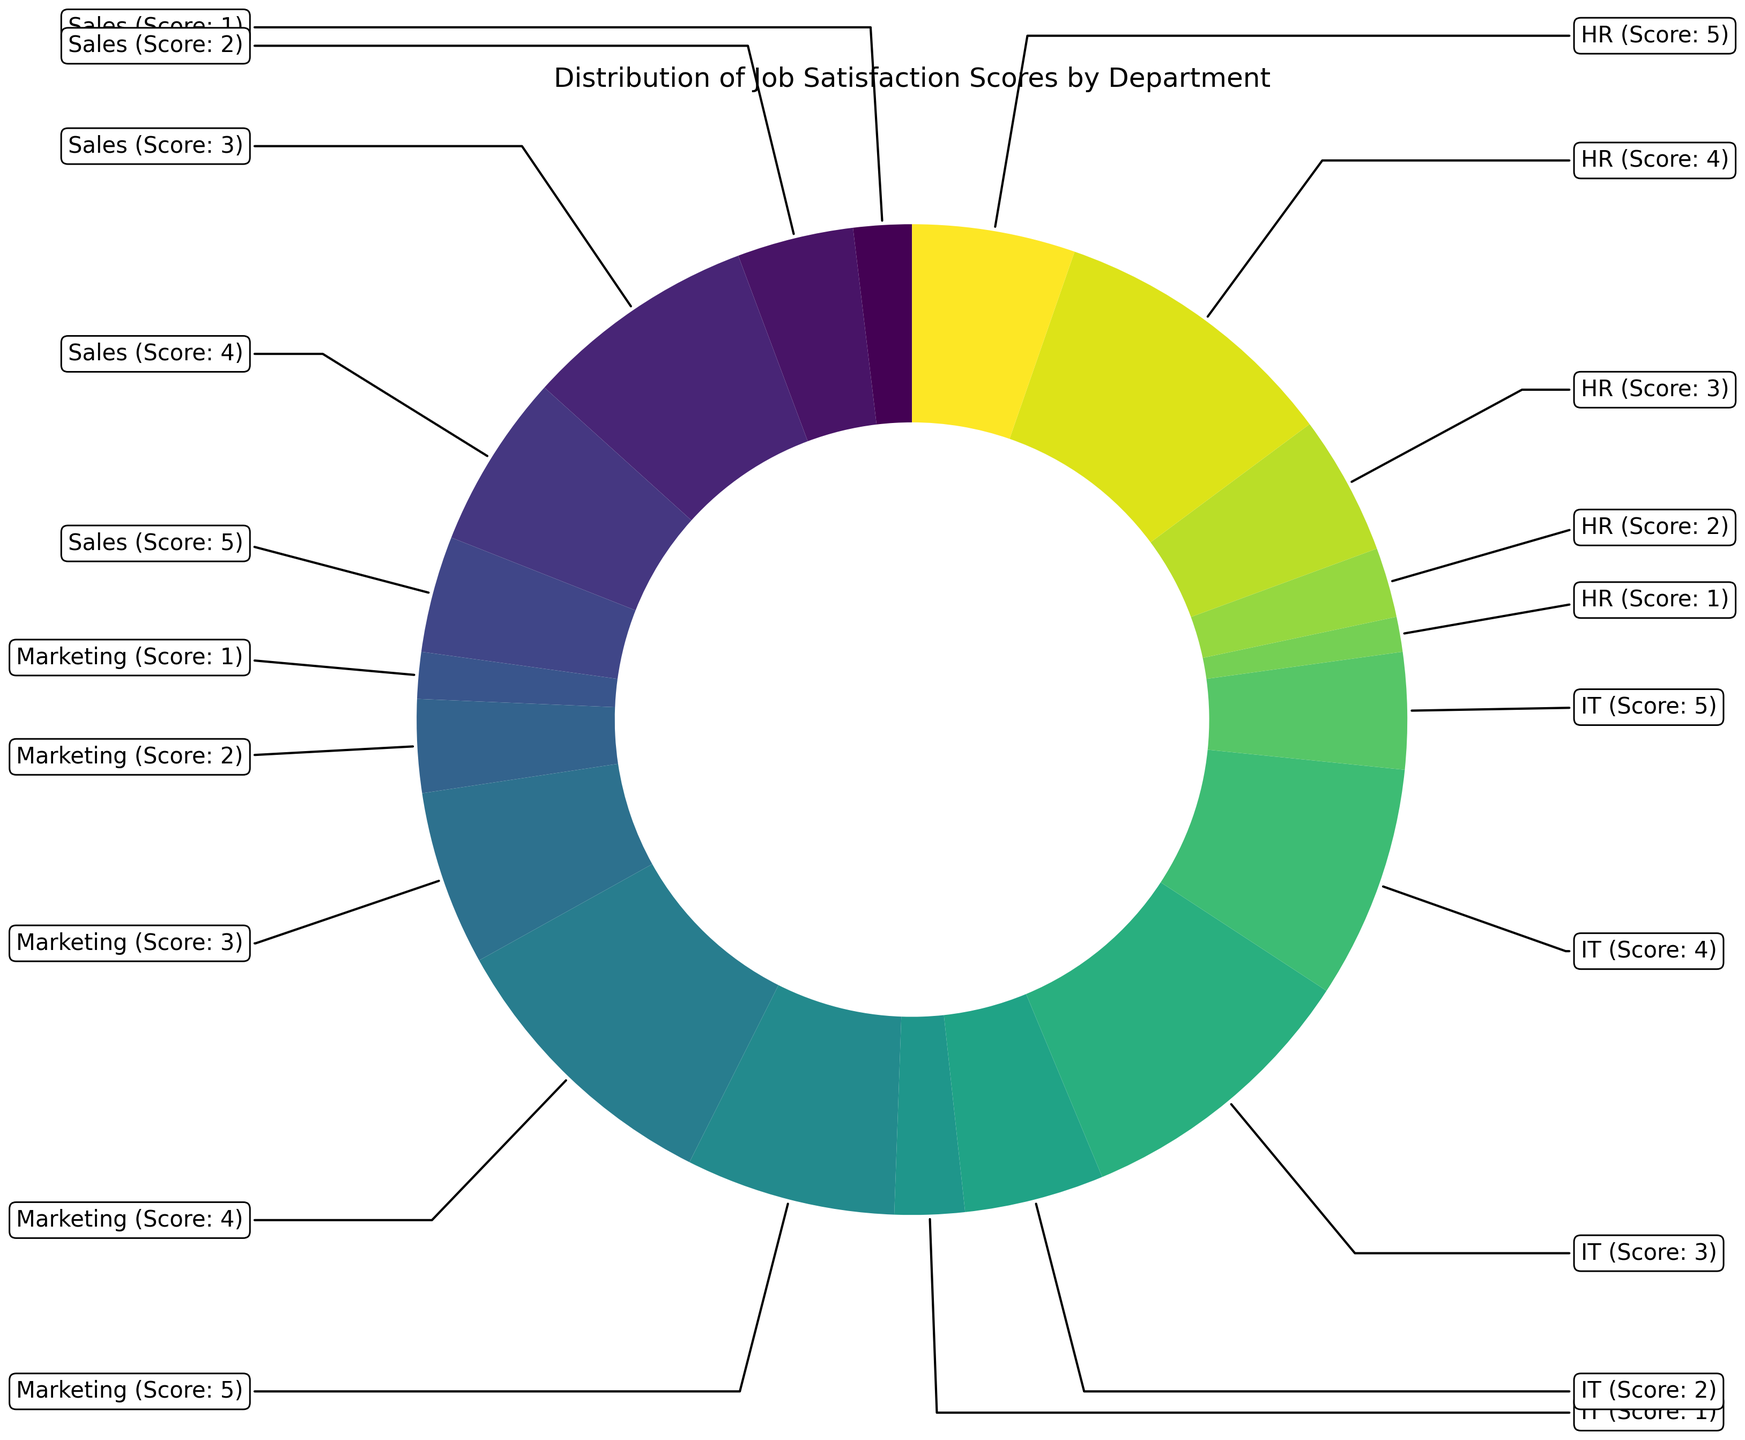What's the largest single wedge in the ring chart, and which department does it belong to? The largest wedge corresponds to the highest count. By observing the size of each segment, we see that Marketing with a Job Satisfaction Score of 4 (25 employees) has the largest wedge.
Answer: Marketing, Score 4 Which department has the highest overall job satisfaction score sum? To find the department with the highest overall job satisfaction score sum, multiply each job satisfaction score by the count of employees for each score and add them up for each department. Summing these products for each department, we get: Sales: (1*5 + 2*10 + 3*20 + 4*15 + 5*10) = 165, Marketing: (1*4 + 2*8 + 3*15 + 4*25 + 5*18) = 304, IT: (1*6 + 2*12 + 3*25 + 4*20 + 5*10) = 202, HR: (1*3 + 2*6 + 3*12 + 4*25 + 5*14) = 215. So, Marketing has the highest overall job satisfaction score sum.
Answer: Marketing Which department has the smallest representation in the ring chart? The smallest wedge indicates the smallest representation. By observing the sizes of the wedges, we can see that HR has the smallest all-around representation, and specifically, the HR department with a Job Satisfaction Score of 1 (3 employees) represents the smallest individual section.
Answer: HR, Score 1 Which department has the most evenly distributed job satisfaction scores? To find the most evenly distributed scores, compare the spread of counts for each job satisfaction score within a department. Sales: 5, 10, 20, 15, 10; Marketing: 4, 8, 15, 25, 18; IT: 6, 12, 25, 20, 10; HR: 3, 6, 12, 25, 14. HR has the counts more spread evenly across the scores compared to other departments.
Answer: HR In which department does the largest drop in satisfaction scores occur from one level to the next? To find the largest drop in satisfaction, calculate the difference in counts for each consecutive job satisfaction score within each department. The differences are: Sales: 5, 10, 10, -5; Marketing: 4, 7, 10, -7; IT: 6, 13, -5, 10; HR: 3, 6, -13, -11. The largest negative difference (-13) is observed in the HR department between job satisfaction scores of 3 and 4.
Answer: HR, between Scores 3 and 4 